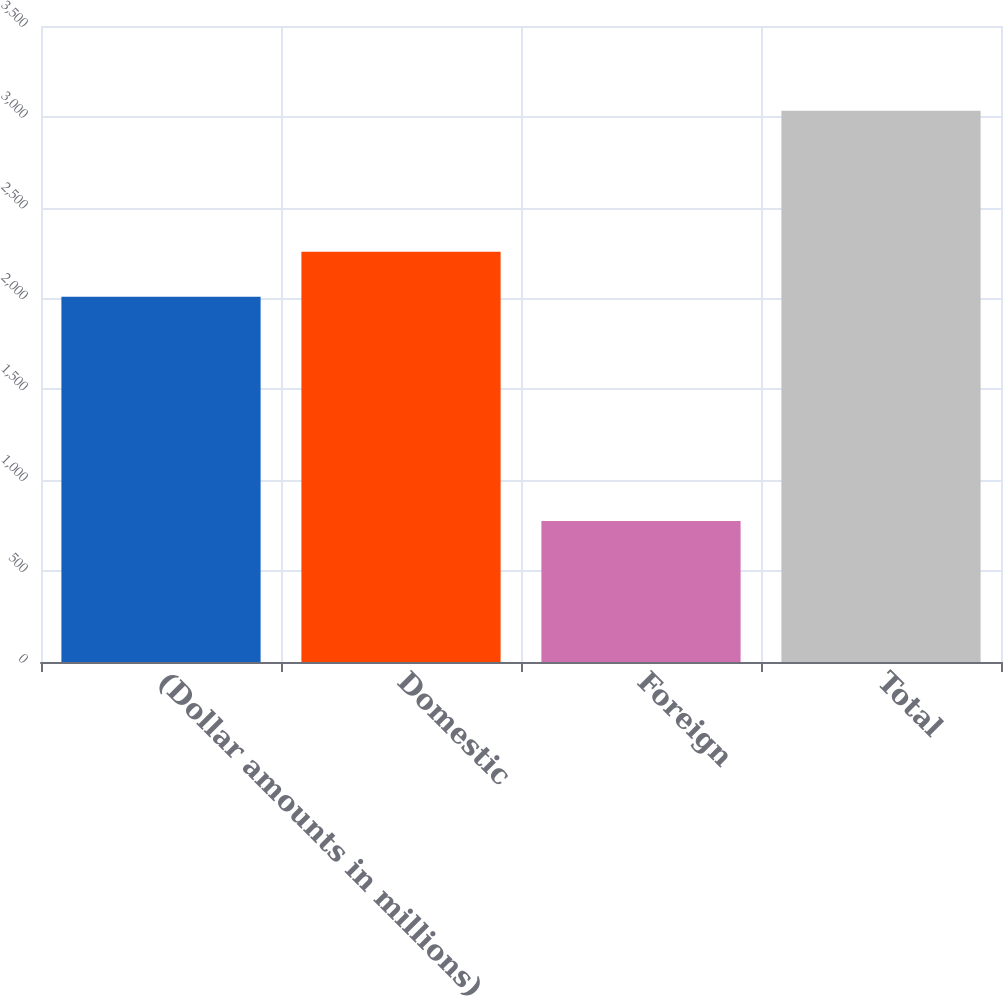<chart> <loc_0><loc_0><loc_500><loc_500><bar_chart><fcel>(Dollar amounts in millions)<fcel>Domestic<fcel>Foreign<fcel>Total<nl><fcel>2010<fcel>2258<fcel>776<fcel>3034<nl></chart> 